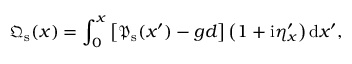Convert formula to latex. <formula><loc_0><loc_0><loc_500><loc_500>{ \mathfrak { Q } } _ { s } ( x ) = \int _ { 0 } ^ { x } \left [ \/ { \mathfrak { P } } _ { s } ( x ^ { \prime } ) - g d \/ \right ] \left ( 1 + i \eta _ { x } ^ { \prime } \right ) d x ^ { \prime } ,</formula> 